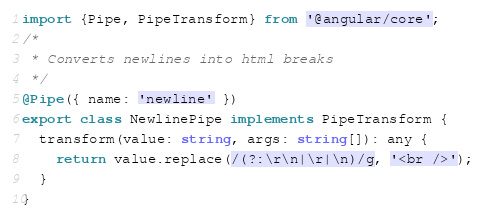Convert code to text. <code><loc_0><loc_0><loc_500><loc_500><_TypeScript_>import {Pipe, PipeTransform} from '@angular/core';
/*
 * Converts newlines into html breaks
 */
@Pipe({ name: 'newline' })
export class NewlinePipe implements PipeTransform {
  transform(value: string, args: string[]): any {
    return value.replace(/(?:\r\n|\r|\n)/g, '<br />');
  }
}
</code> 